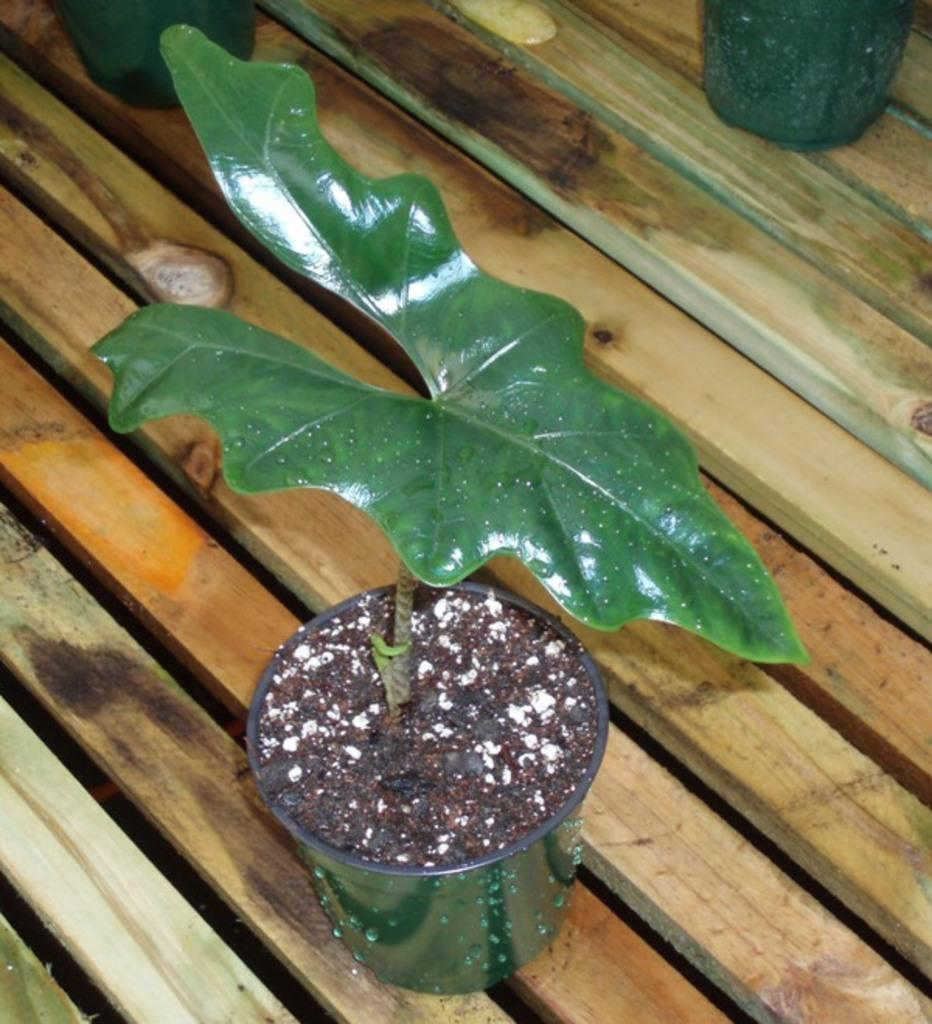What is the main subject in the center of the image? There is a plant pot in the center of the image. Where is the plant pot located? The plant pot is on a bench. Are there any other plant pots visible in the image? Yes, there are other pots at the top side of the image. Can you see a stream of water flowing near the plant pots in the image? There is no stream of water visible in the image. 